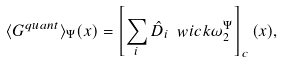<formula> <loc_0><loc_0><loc_500><loc_500>\langle G ^ { q u a n t } \rangle _ { \Psi } ( x ) = \left [ \sum _ { i } \hat { D } _ { i } \ w i c k { \omega _ { 2 } ^ { \Psi } } \right ] _ { c } ( x ) ,</formula> 